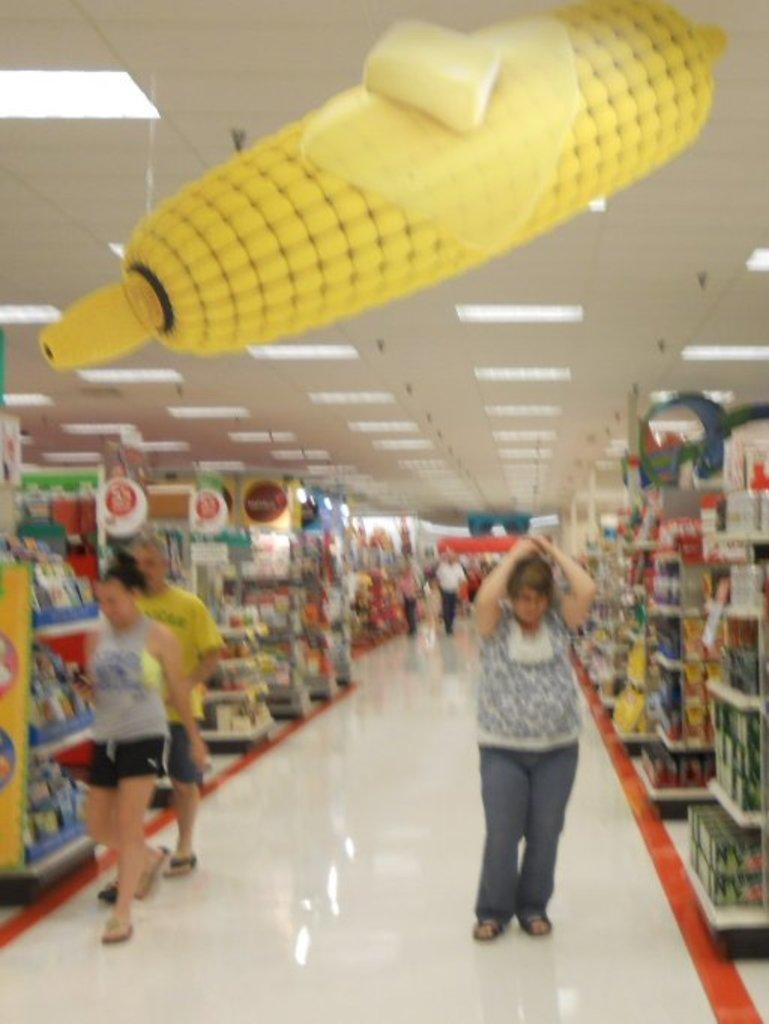Please provide a concise description of this image. This picture is blur, there are people and we can see floor, boards and objects in racks. At the top we can see lights, ceiling and maize. 